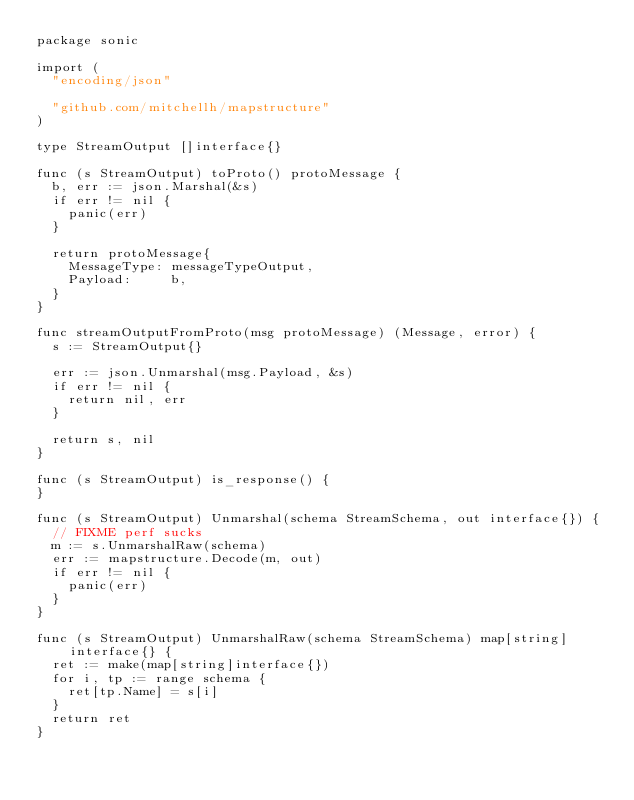<code> <loc_0><loc_0><loc_500><loc_500><_Go_>package sonic

import (
	"encoding/json"

	"github.com/mitchellh/mapstructure"
)

type StreamOutput []interface{}

func (s StreamOutput) toProto() protoMessage {
	b, err := json.Marshal(&s)
	if err != nil {
		panic(err)
	}

	return protoMessage{
		MessageType: messageTypeOutput,
		Payload:     b,
	}
}

func streamOutputFromProto(msg protoMessage) (Message, error) {
	s := StreamOutput{}

	err := json.Unmarshal(msg.Payload, &s)
	if err != nil {
		return nil, err
	}

	return s, nil
}

func (s StreamOutput) is_response() {
}

func (s StreamOutput) Unmarshal(schema StreamSchema, out interface{}) {
	// FIXME perf sucks
	m := s.UnmarshalRaw(schema)
	err := mapstructure.Decode(m, out)
	if err != nil {
		panic(err)
	}
}

func (s StreamOutput) UnmarshalRaw(schema StreamSchema) map[string]interface{} {
	ret := make(map[string]interface{})
	for i, tp := range schema {
		ret[tp.Name] = s[i]
	}
	return ret
}
</code> 